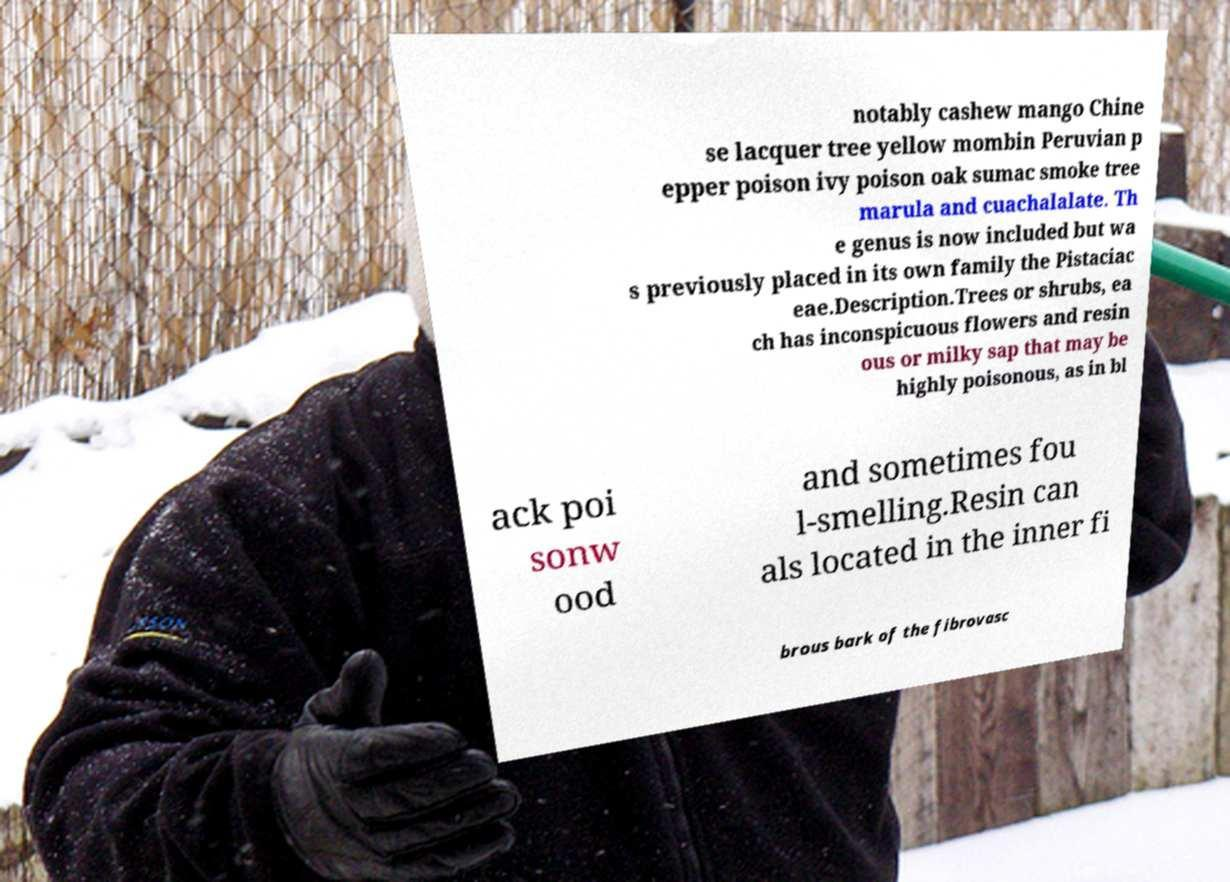Can you read and provide the text displayed in the image?This photo seems to have some interesting text. Can you extract and type it out for me? notably cashew mango Chine se lacquer tree yellow mombin Peruvian p epper poison ivy poison oak sumac smoke tree marula and cuachalalate. Th e genus is now included but wa s previously placed in its own family the Pistaciac eae.Description.Trees or shrubs, ea ch has inconspicuous flowers and resin ous or milky sap that may be highly poisonous, as in bl ack poi sonw ood and sometimes fou l-smelling.Resin can als located in the inner fi brous bark of the fibrovasc 